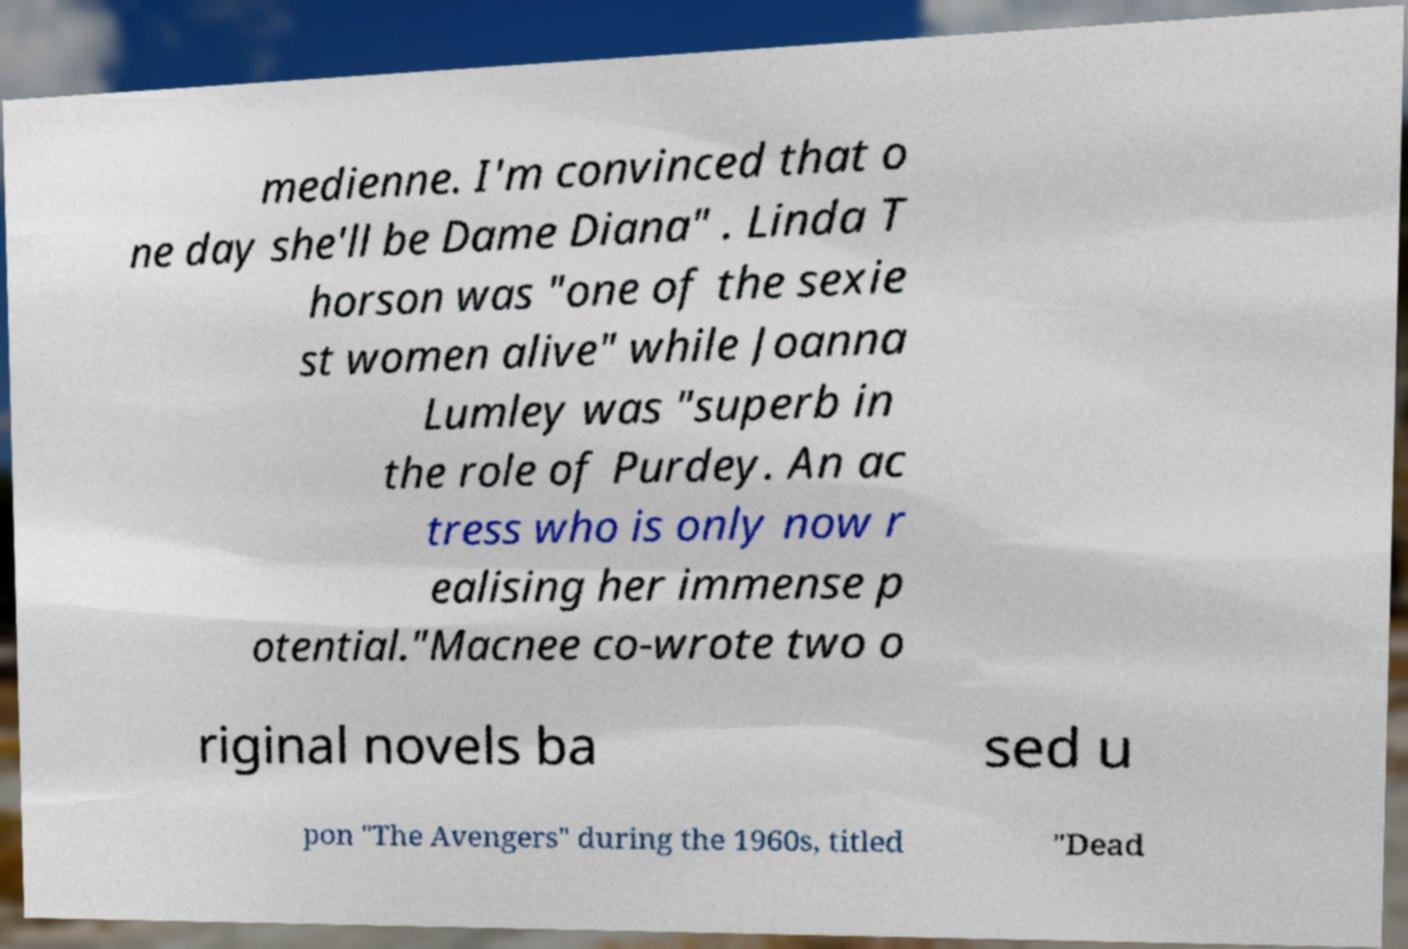Could you extract and type out the text from this image? medienne. I'm convinced that o ne day she'll be Dame Diana" . Linda T horson was "one of the sexie st women alive" while Joanna Lumley was "superb in the role of Purdey. An ac tress who is only now r ealising her immense p otential."Macnee co-wrote two o riginal novels ba sed u pon "The Avengers" during the 1960s, titled "Dead 